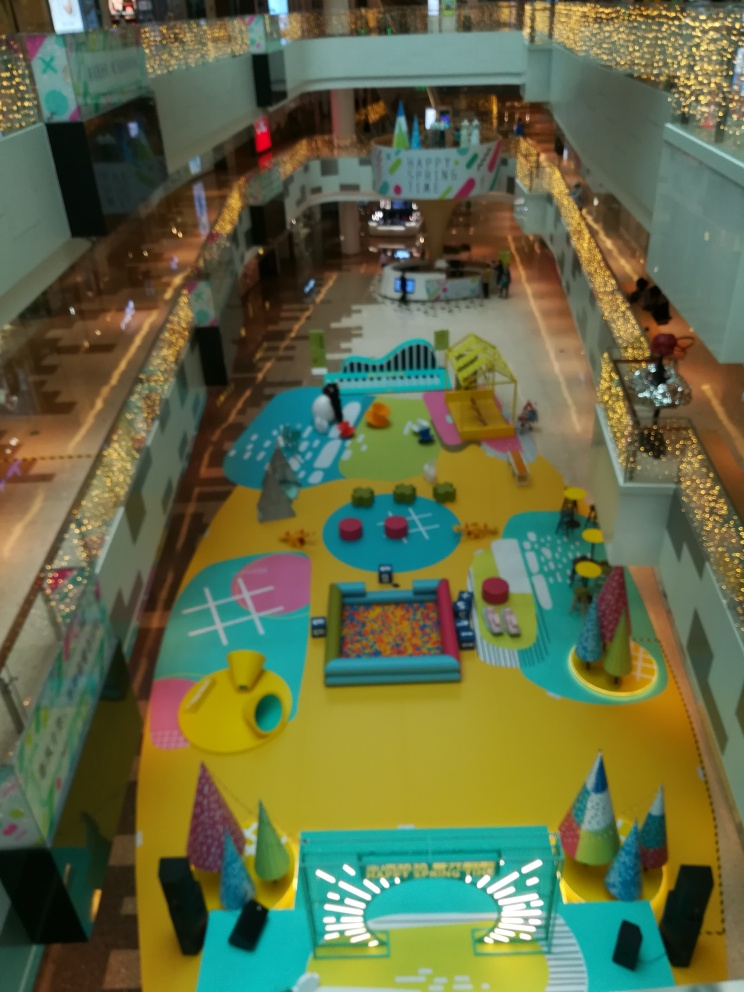What do you think is the purpose of this kind of indoor space in a shopping center? This kind of indoor space serves multiple purposes. Primarily, it provides a safe and engaging area for children to play while their parents or guardians shop. It also enhances the shopping center's family-friendly atmosphere, encouraging longer visits and repeat customers. Additionally, it's a community space that can host events and foster social interactions among children. 